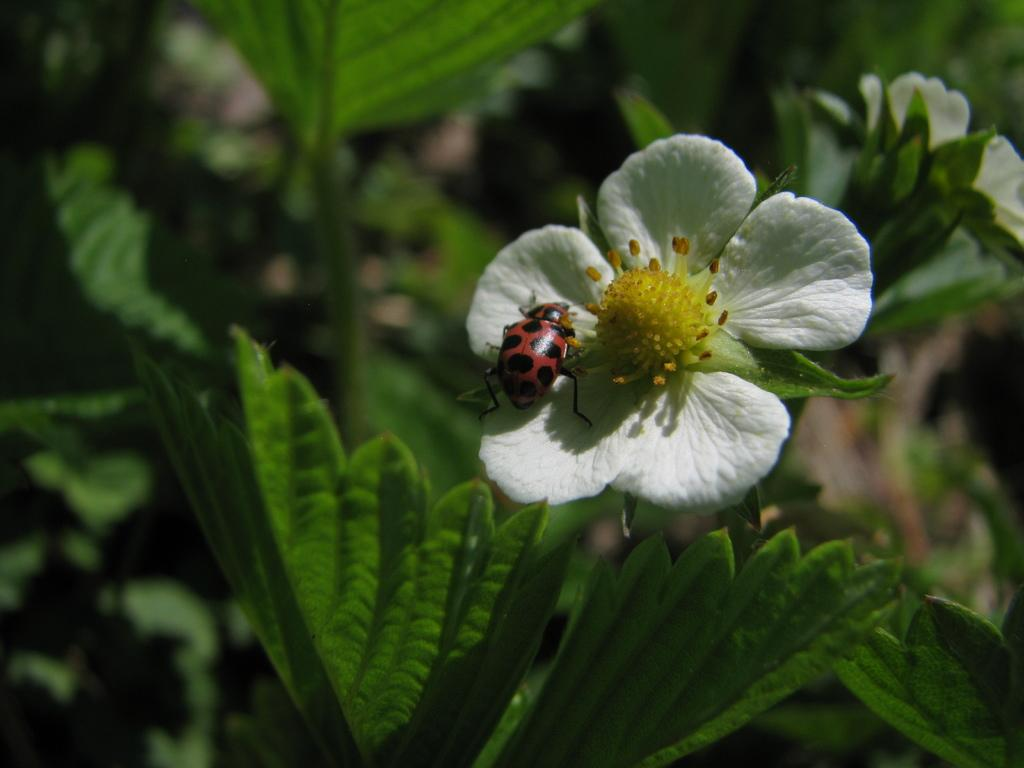What type of living organisms can be seen in the image? Plants can be seen in the image. What color are the flowers on the plants? The flowers on the plants are white. Where are the flowers located in the image? The flowers are on the right side of the image. Is there any other living organism present on the flowers? Yes, there is an insect on one of the flowers. What grade did the student receive on their breakfast game in the image? There is no student, breakfast game, or grade present in the image. 